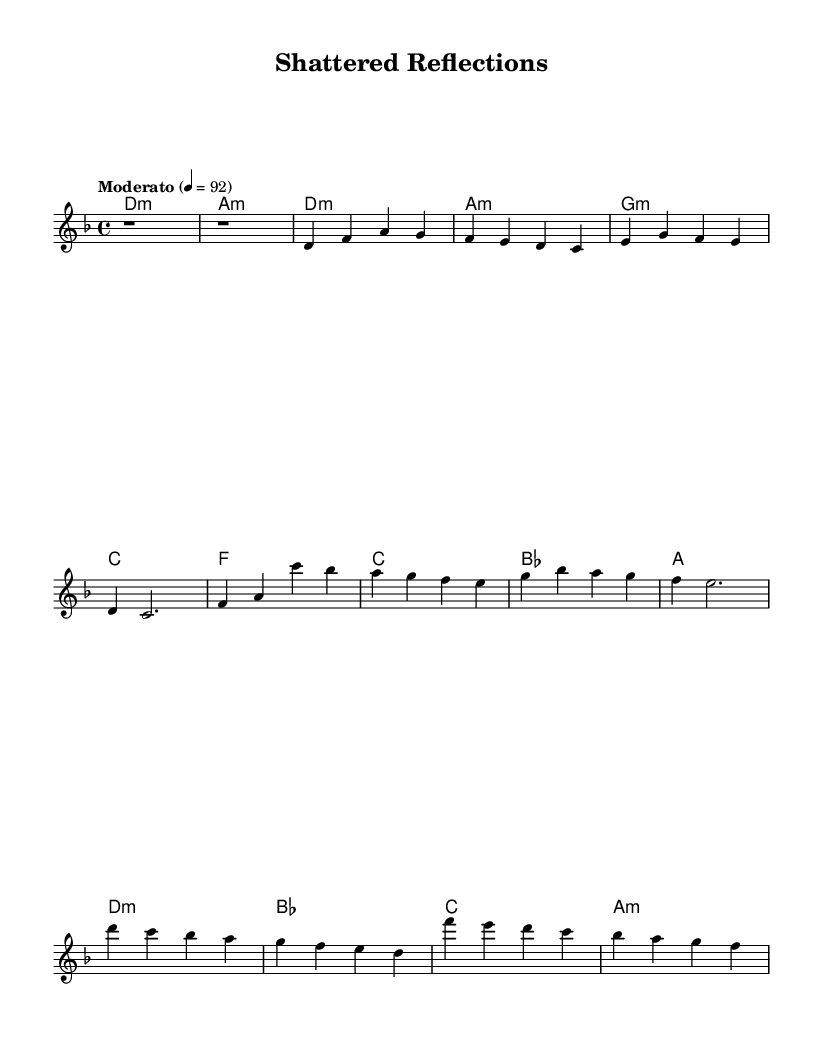What is the key signature of this music? The key signature is D minor, indicated by one flat (B flat) in the music sheet.
Answer: D minor What is the time signature of this music? The time signature is 4/4, meaning there are four beats in each measure and the quarter note gets one beat.
Answer: 4/4 What is the tempo marking of this piece? The tempo marking is "Moderato," which usually indicates a moderate speed, and is set at 92 beats per minute.
Answer: Moderato How many measures are in the intro? The intro consists of 2 measures, as seen from the notation which clearly shows two rests (r1) for each of the two measures.
Answer: 2 measures What chord is played during the pre-chorus? The pre-chorus features the chords F, C, B flat, and A, as indicated sequentially in the harmonies section.
Answer: F, C, B flat, A Which section of the music has the highest note? The highest note appears in the chorus section, specifically at the pitch C' (C in the octave above middle C).
Answer: C' What emotional theme does this K-Pop piece explore? The piece explores introspective themes related to the psychological effects of witnessing trauma, as inferred from the title "Shattered Reflections."
Answer: Psychological effects 